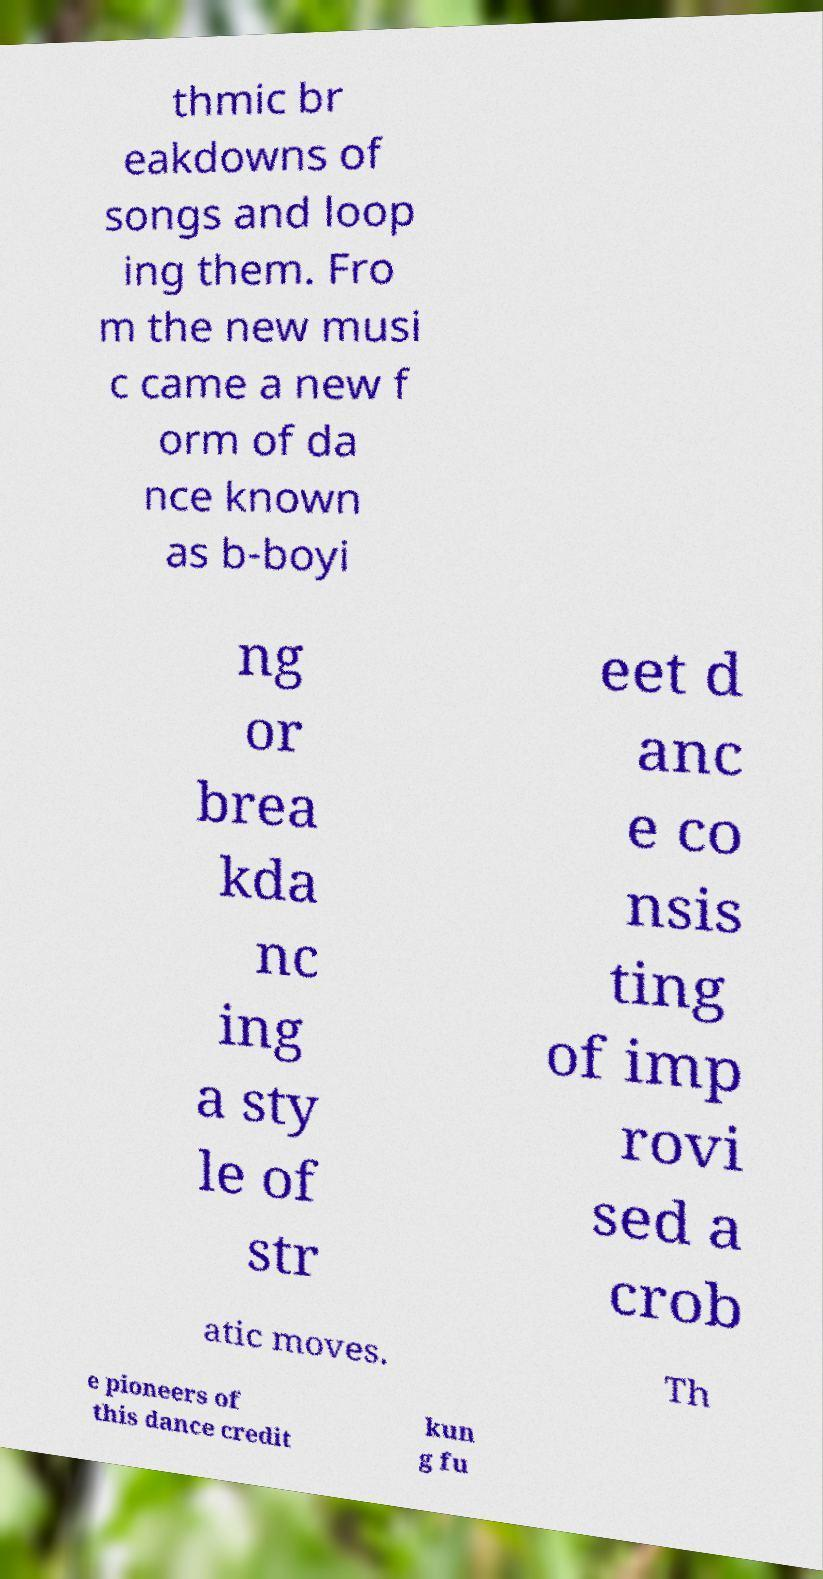Please read and relay the text visible in this image. What does it say? thmic br eakdowns of songs and loop ing them. Fro m the new musi c came a new f orm of da nce known as b-boyi ng or brea kda nc ing a sty le of str eet d anc e co nsis ting of imp rovi sed a crob atic moves. Th e pioneers of this dance credit kun g fu 